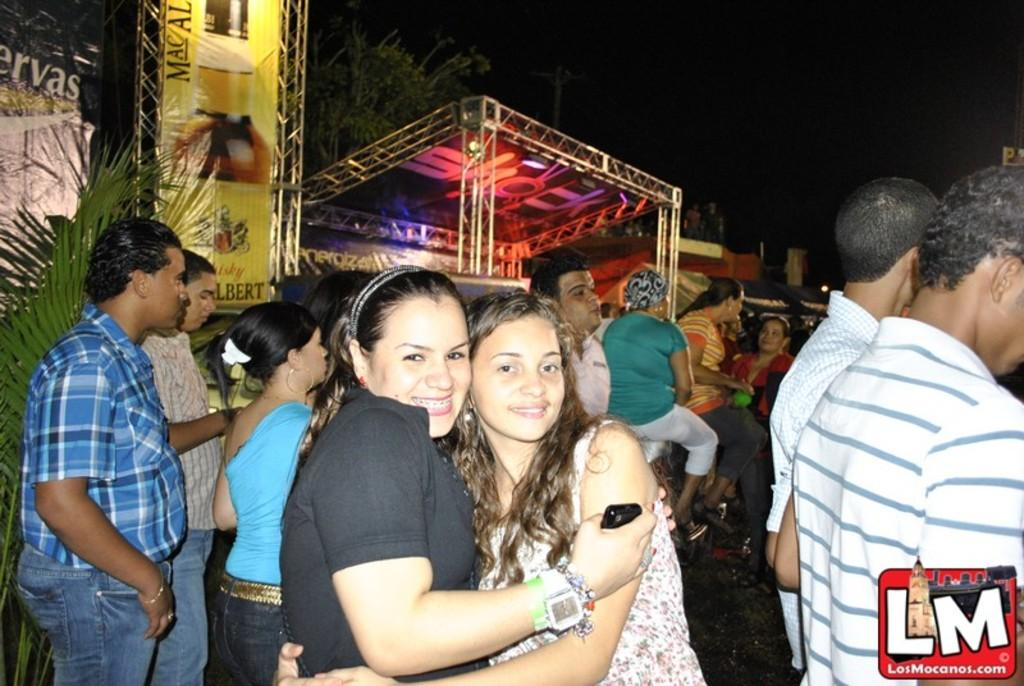How many people are in the image? There is a group of people in the image, but the exact number is not specified. What can be observed about the clothing of the people in the image? The people are wearing different color dresses. What is the purpose of the banner in the image? The purpose of the banner is not specified, but it is present in the image. What is the setting of the image? The image features a stage, which suggests it might be a performance or event. What can be seen in the background of the image? There are many trees and the sky visible in the background of the image. What type of mark can be seen on the trees in the image? There is no mention of any marks on the trees in the image. What causes the burst of color in the image? There is no burst of color mentioned in the image; the people are wearing different color dresses, but this is not described as a burst of color. 